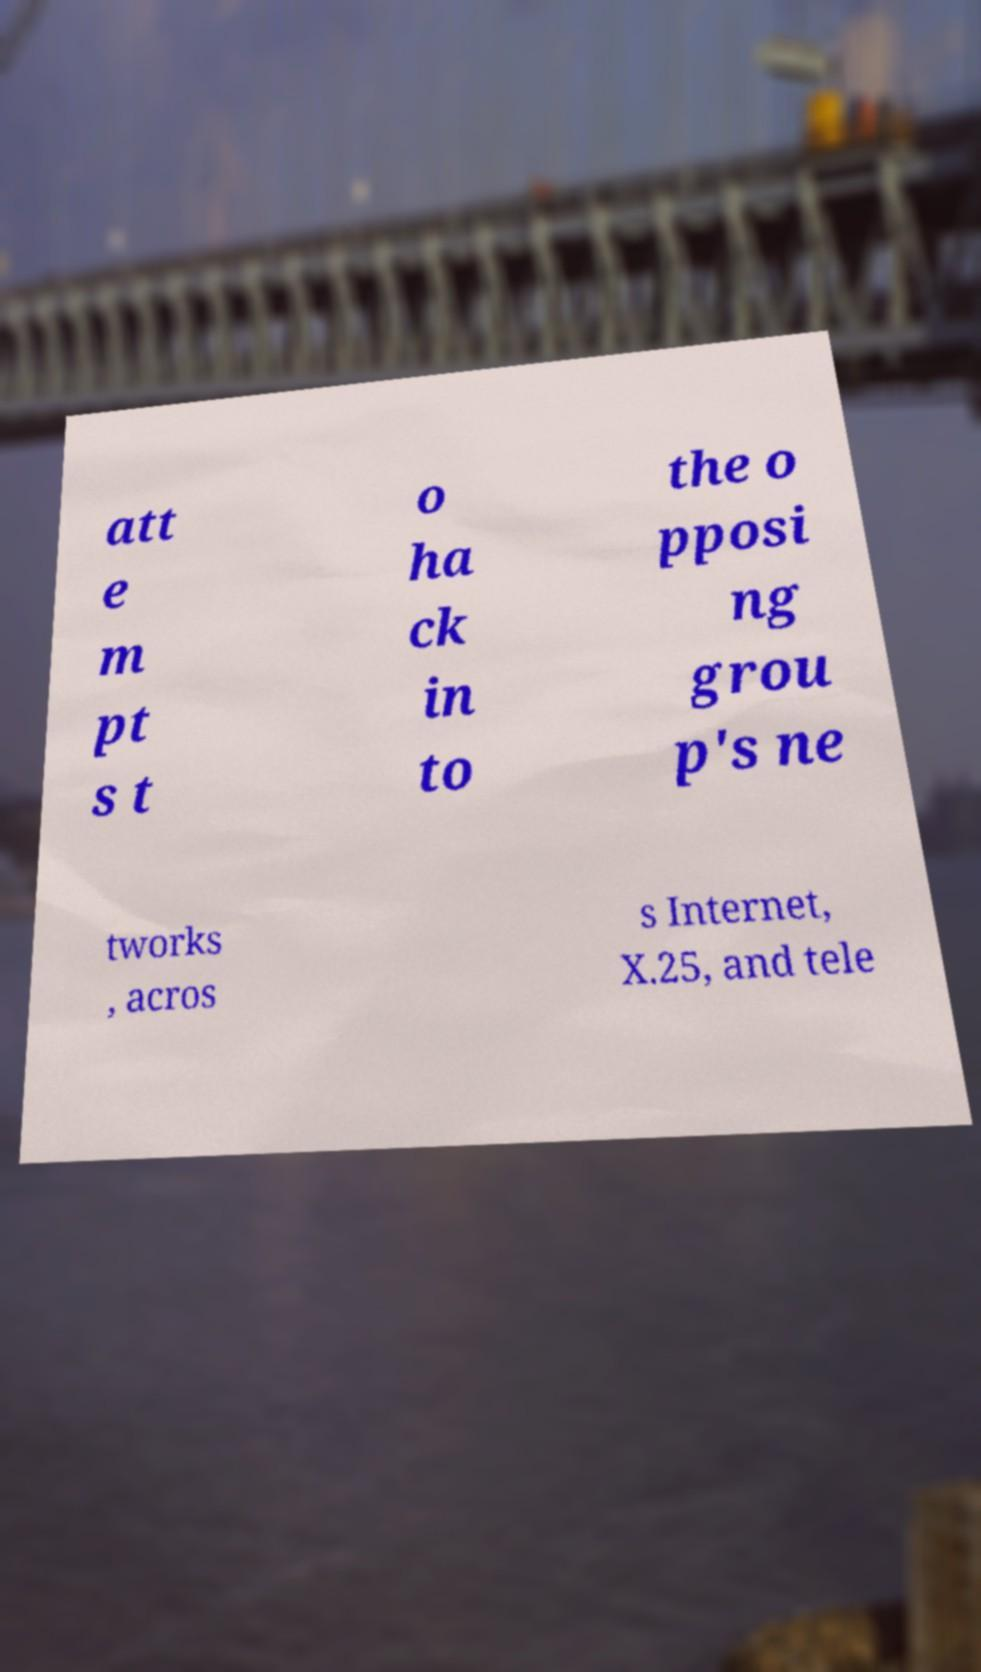Can you read and provide the text displayed in the image?This photo seems to have some interesting text. Can you extract and type it out for me? att e m pt s t o ha ck in to the o pposi ng grou p's ne tworks , acros s Internet, X.25, and tele 